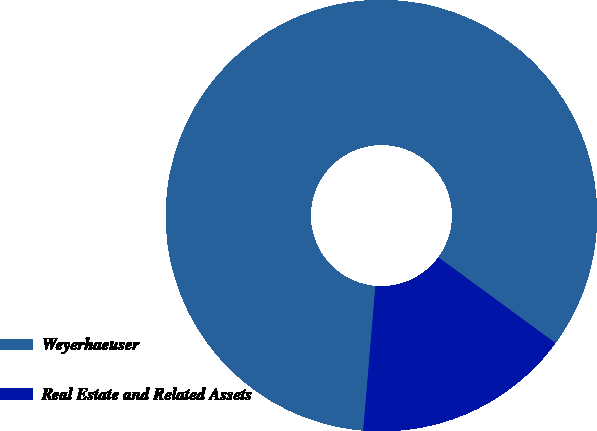<chart> <loc_0><loc_0><loc_500><loc_500><pie_chart><fcel>Weyerhaeuser<fcel>Real Estate and Related Assets<nl><fcel>83.72%<fcel>16.28%<nl></chart> 